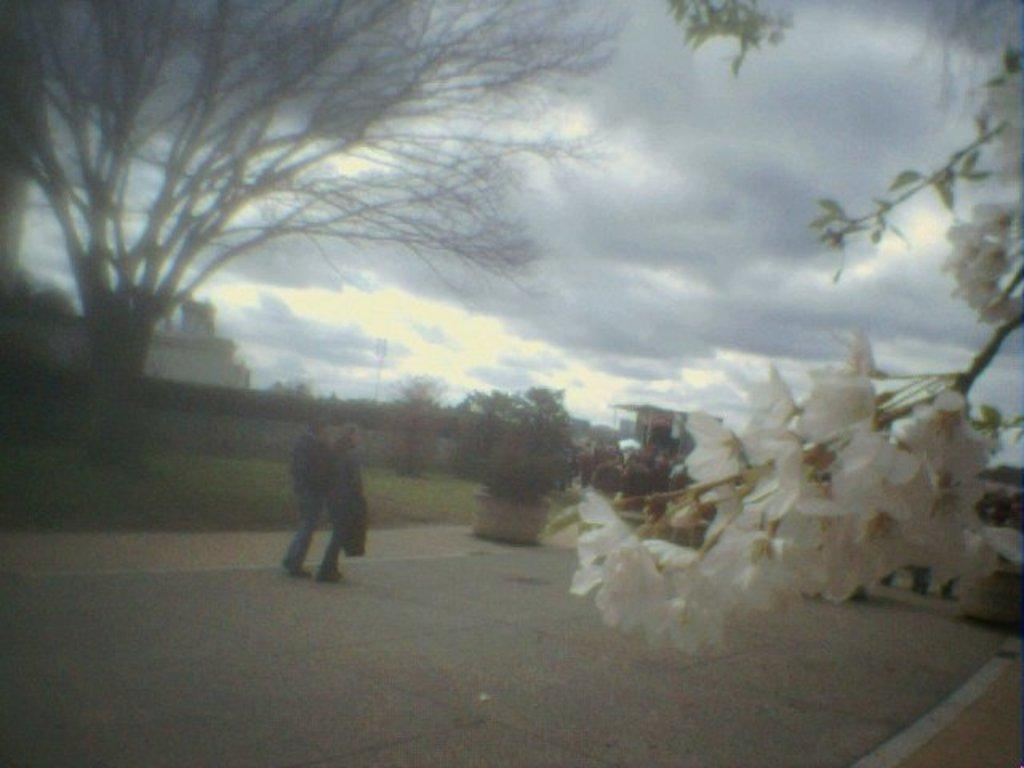What are the people in the image doing? There are persons standing on the floor in the image. What type of vegetation can be seen in the image? There are houseplants and trees in the image. What type of structures are visible in the image? There are buildings in the image. What type of lighting is present in the image? Flood lights are present in the image. What type of flora can be seen on a tree in the image? There are flowers on a tree in the image. What is visible in the background of the image? The sky with clouds is visible in the background of the image. How many pizzas are being kicked around in the image? There are no pizzas or kicking activities present in the image. What type of loss is being experienced by the people in the image? There is no indication of loss or any negative emotions in the image; the people are simply standing on the floor. 